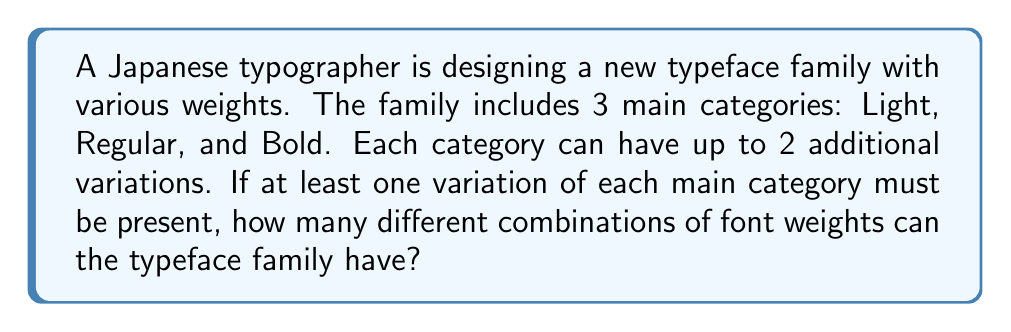What is the answer to this math problem? Let's approach this step-by-step:

1) We have 3 main categories: Light, Regular, and Bold.

2) Each category can have up to 2 additional variations. This means each category can have 1, 2, or 3 options.

3) We can represent this as a combination problem where we need to choose options for each category.

4) For each category:
   - 1 option: $\binom{3}{1} = 3$ ways
   - 2 options: $\binom{3}{2} = 3$ ways
   - 3 options: $\binom{3}{3} = 1$ way

5) So, each category has 7 possible configurations (3 + 3 + 1 = 7).

6) Since we need at least one variation of each main category, we can't have 0 options for any category.

7) The total number of combinations is the product of the possibilities for each category:

   $$ 7 \times 7 \times 7 = 343 $$

Therefore, there are 343 different combinations of font weights possible for this typeface family.
Answer: 343 